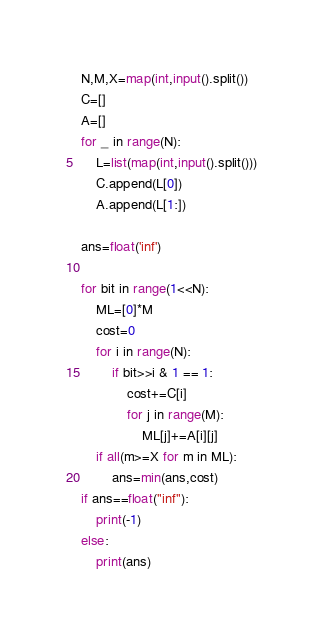Convert code to text. <code><loc_0><loc_0><loc_500><loc_500><_Python_>N,M,X=map(int,input().split())
C=[]
A=[]
for _ in range(N):
    L=list(map(int,input().split()))
    C.append(L[0])
    A.append(L[1:])

ans=float('inf')

for bit in range(1<<N):
    ML=[0]*M
    cost=0
    for i in range(N):
        if bit>>i & 1 == 1:
            cost+=C[i]
            for j in range(M):
                ML[j]+=A[i][j]
    if all(m>=X for m in ML):
        ans=min(ans,cost)
if ans==float("inf"):
    print(-1)
else:
    print(ans)


</code> 